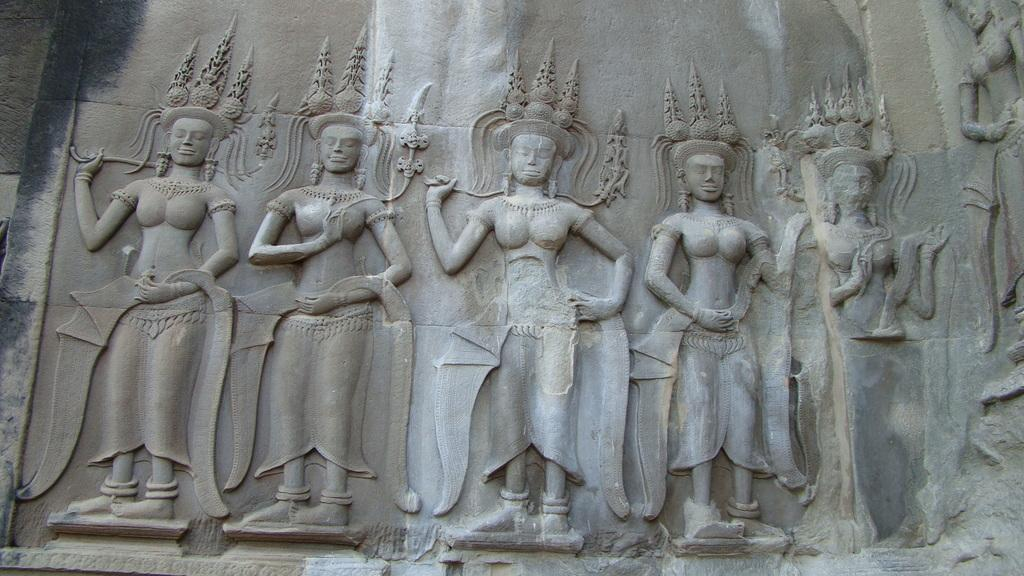What is depicted on the wall in the image? There are sculptures on the wall in the image. What memory does the actor have about the sculptures in the image? There is no actor present in the image, and therefore no memory can be attributed to them regarding the sculptures. 